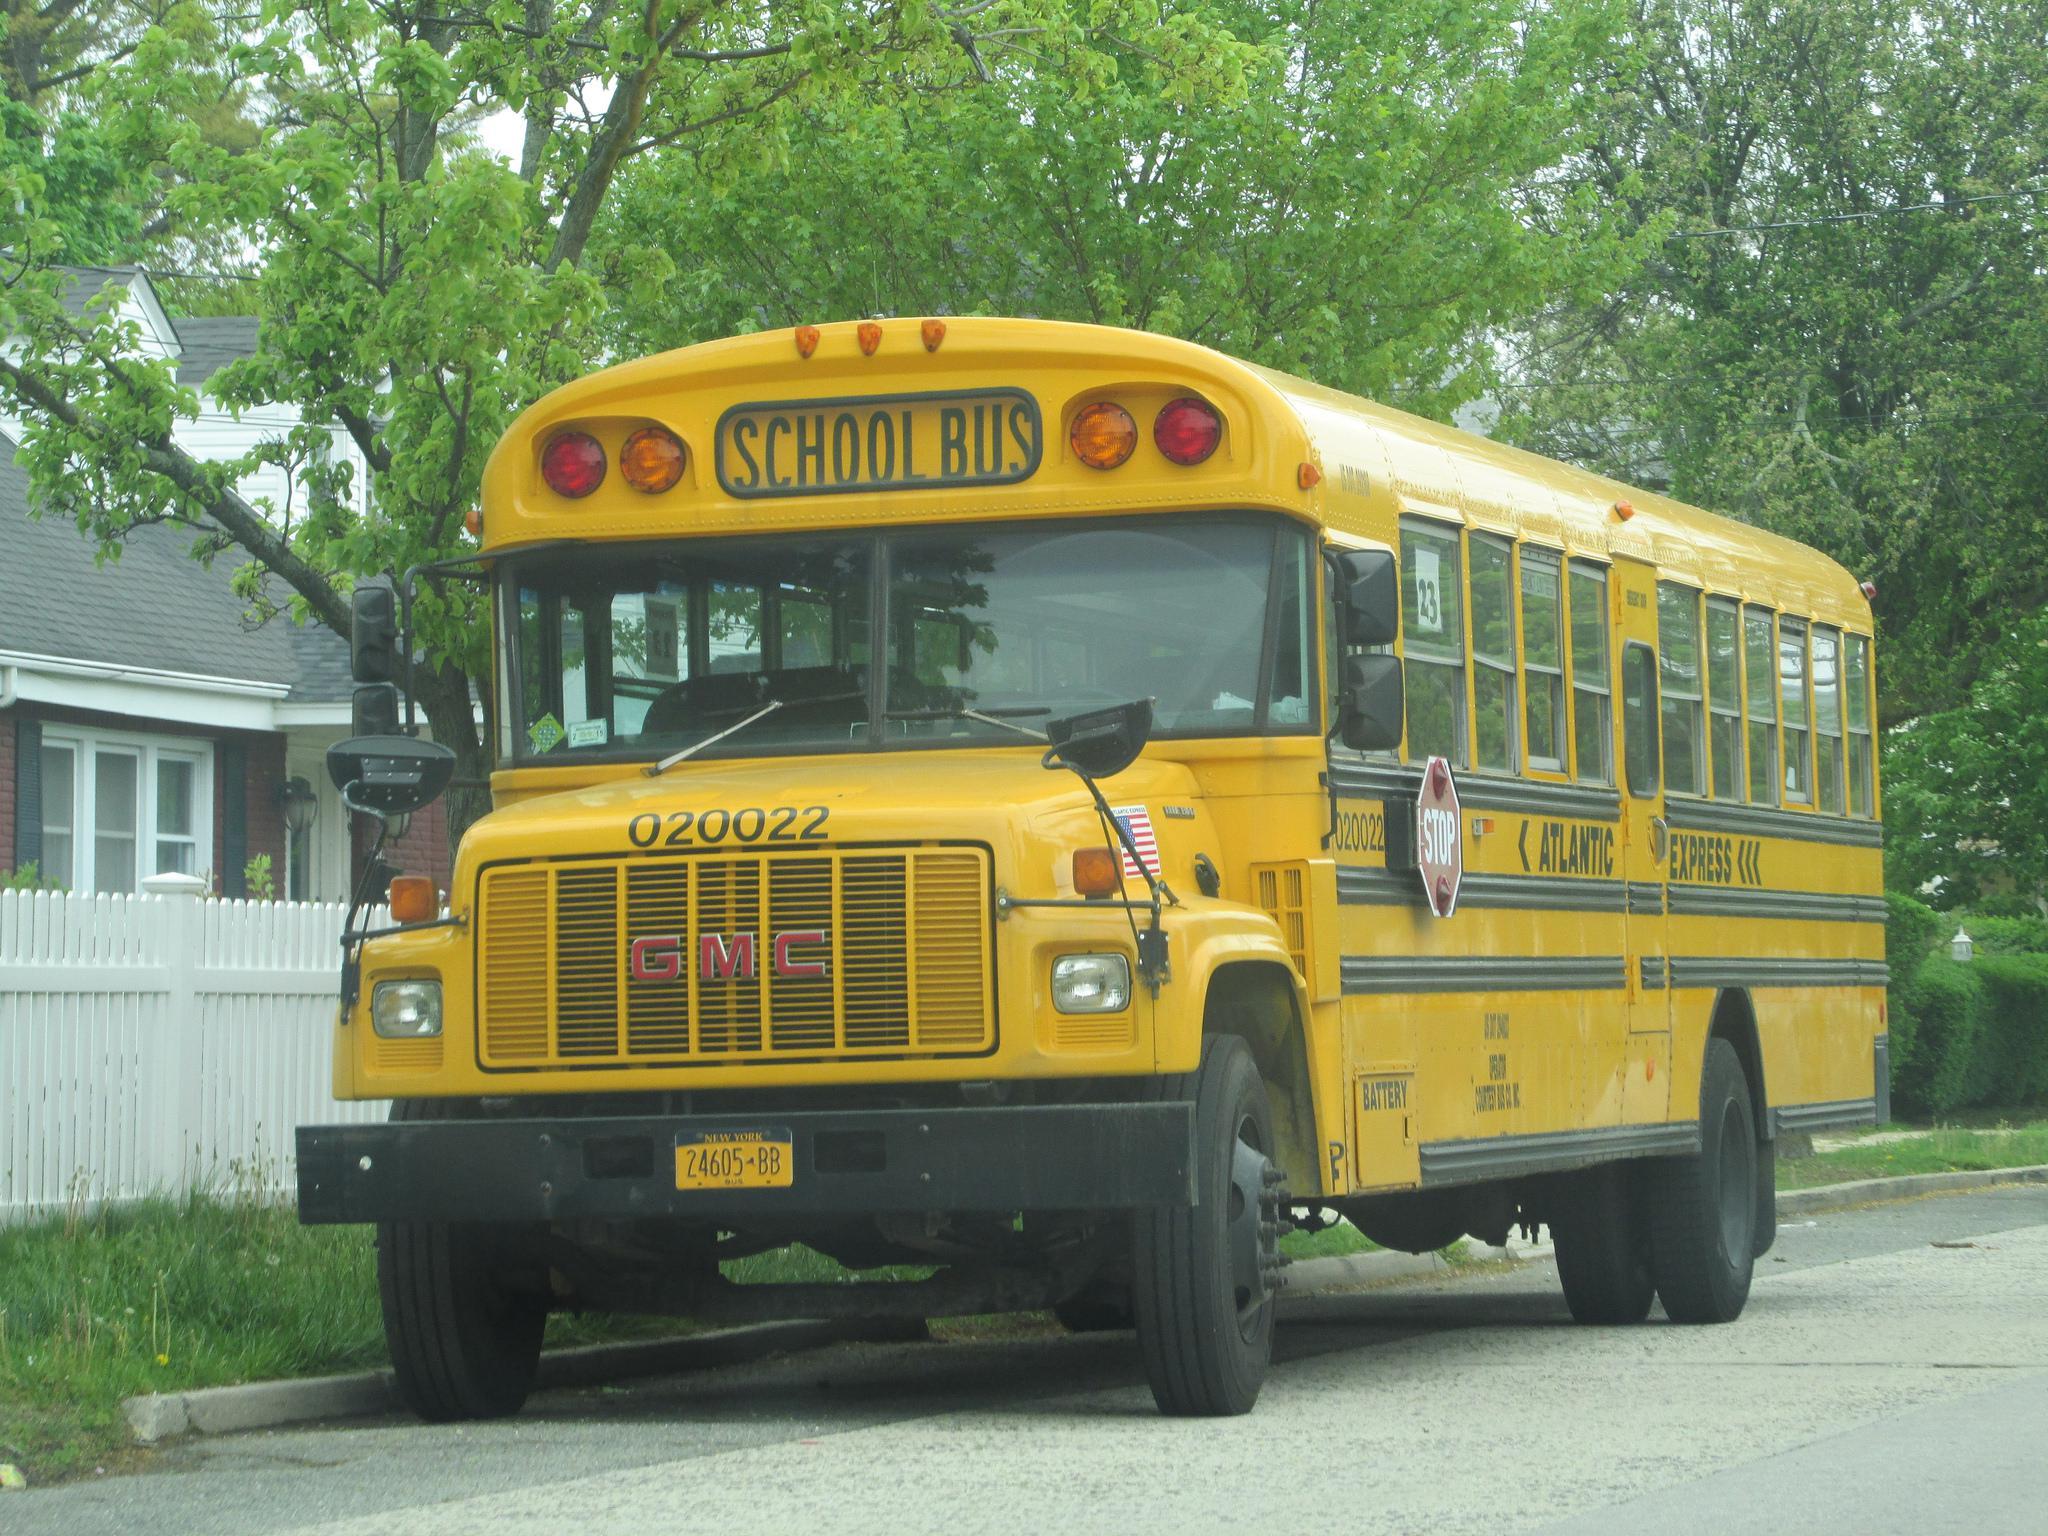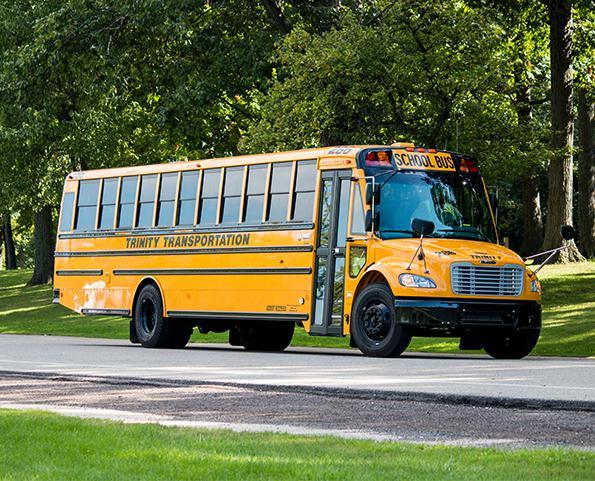The first image is the image on the left, the second image is the image on the right. For the images shown, is this caption "The entry doors are visible on at least one of the buses." true? Answer yes or no. Yes. The first image is the image on the left, the second image is the image on the right. For the images displayed, is the sentence "Each image shows a yellow bus with its non-flat front visible, and at least one bus is shown with the passenger entry door visible." factually correct? Answer yes or no. Yes. 